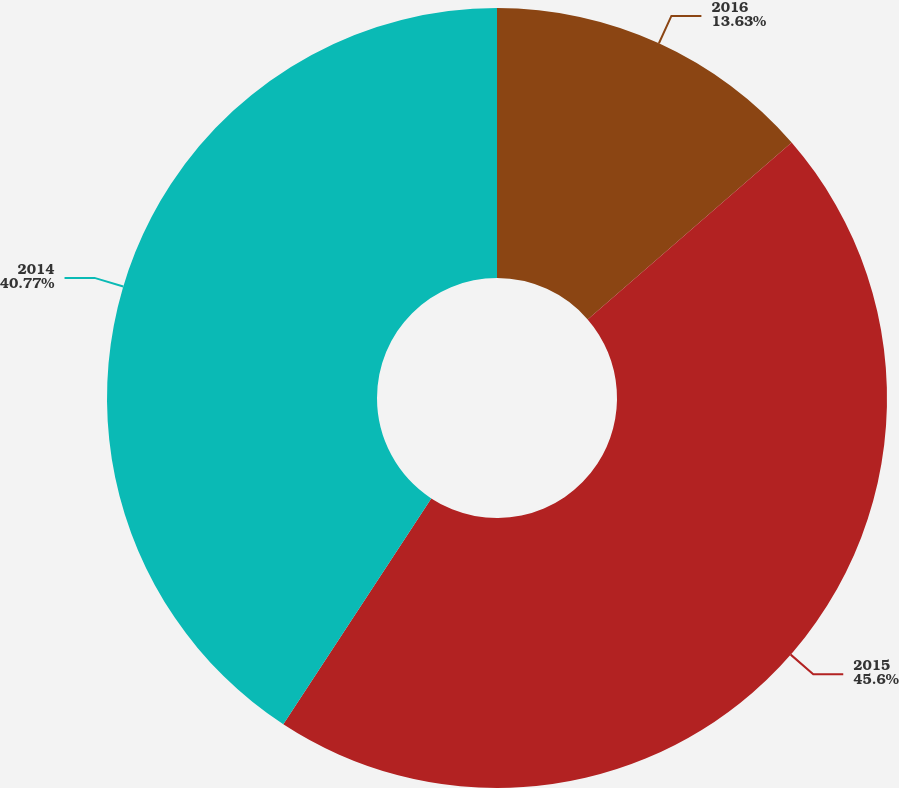Convert chart. <chart><loc_0><loc_0><loc_500><loc_500><pie_chart><fcel>2016<fcel>2015<fcel>2014<nl><fcel>13.63%<fcel>45.6%<fcel>40.77%<nl></chart> 